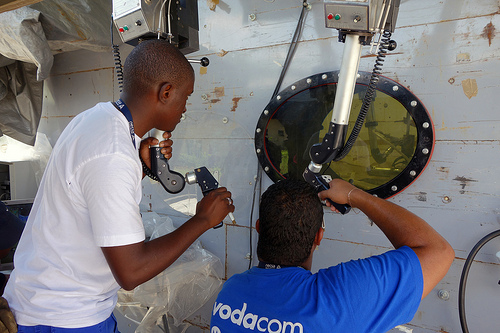<image>
Is the head to the left of the machinery? No. The head is not to the left of the machinery. From this viewpoint, they have a different horizontal relationship. 